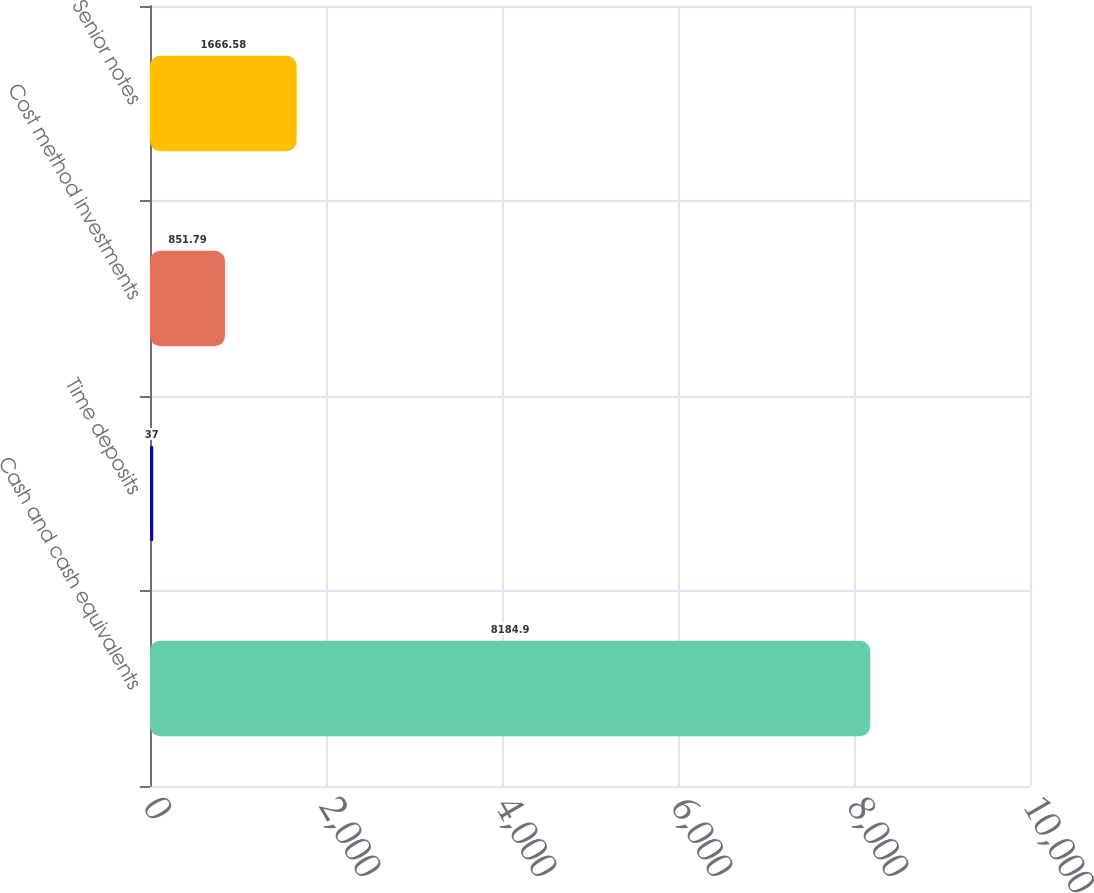<chart> <loc_0><loc_0><loc_500><loc_500><bar_chart><fcel>Cash and cash equivalents<fcel>Time deposits<fcel>Cost method investments<fcel>Senior notes<nl><fcel>8184.9<fcel>37<fcel>851.79<fcel>1666.58<nl></chart> 